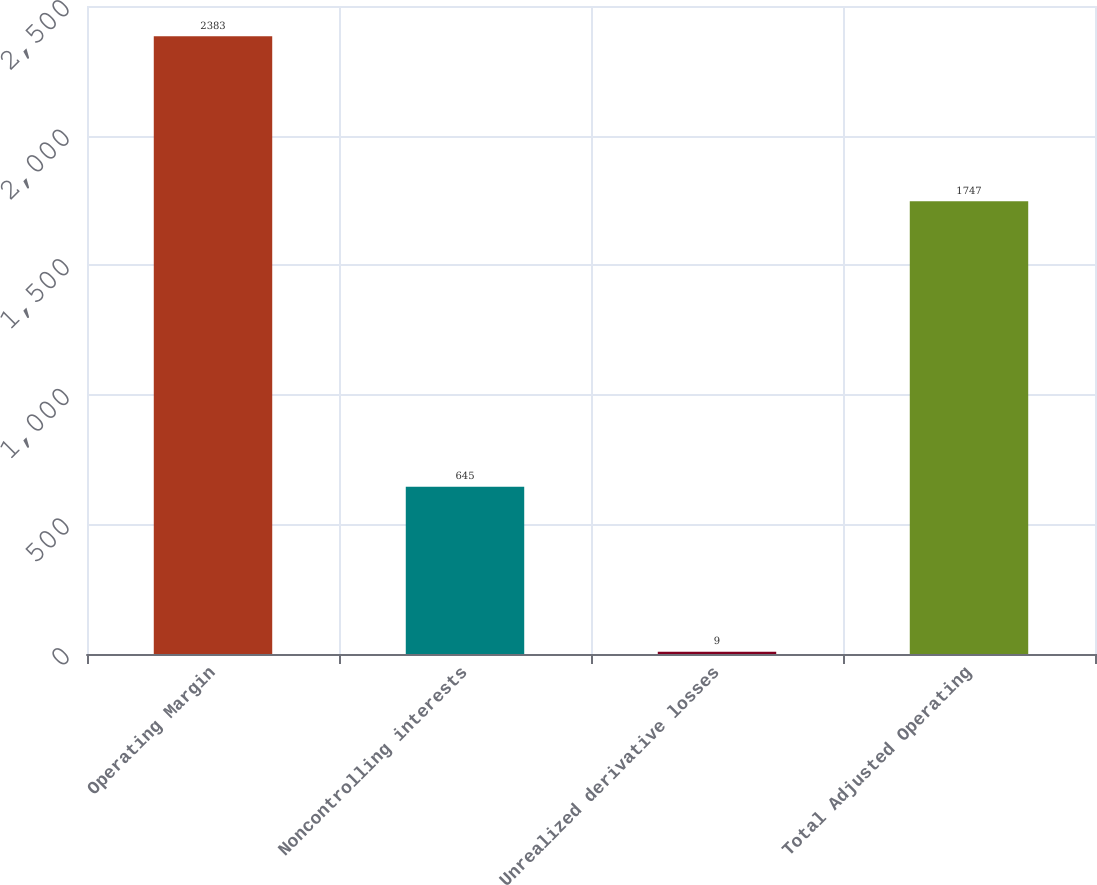Convert chart to OTSL. <chart><loc_0><loc_0><loc_500><loc_500><bar_chart><fcel>Operating Margin<fcel>Noncontrolling interests<fcel>Unrealized derivative losses<fcel>Total Adjusted Operating<nl><fcel>2383<fcel>645<fcel>9<fcel>1747<nl></chart> 